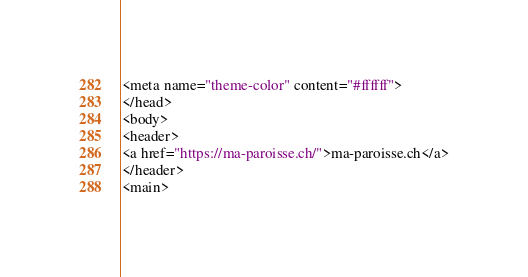<code> <loc_0><loc_0><loc_500><loc_500><_HTML_><meta name="theme-color" content="#ffffff">
</head>
<body>
<header>
<a href="https://ma-paroisse.ch/">ma-paroisse.ch</a>
</header>
<main></code> 